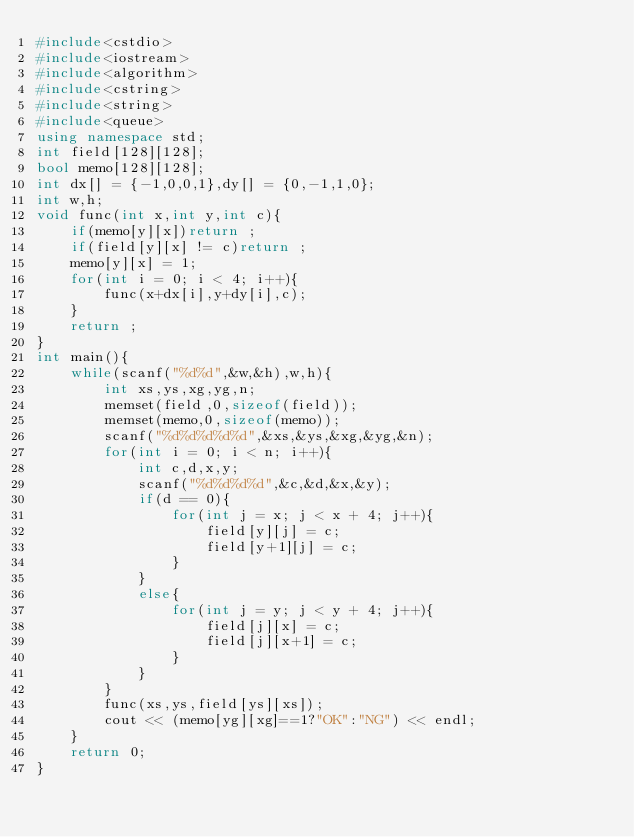<code> <loc_0><loc_0><loc_500><loc_500><_C++_>#include<cstdio>
#include<iostream>
#include<algorithm>
#include<cstring>
#include<string>
#include<queue>
using namespace std;
int field[128][128];
bool memo[128][128];
int dx[] = {-1,0,0,1},dy[] = {0,-1,1,0};
int w,h;
void func(int x,int y,int c){
	if(memo[y][x])return ;
	if(field[y][x] != c)return ;
	memo[y][x] = 1;
	for(int i = 0; i < 4; i++){
		func(x+dx[i],y+dy[i],c);
	}
	return ;
}
int main(){
	while(scanf("%d%d",&w,&h),w,h){
		int xs,ys,xg,yg,n;
		memset(field,0,sizeof(field));
		memset(memo,0,sizeof(memo));
		scanf("%d%d%d%d%d",&xs,&ys,&xg,&yg,&n);
		for(int i = 0; i < n; i++){
			int c,d,x,y;
			scanf("%d%d%d%d",&c,&d,&x,&y);
			if(d == 0){
				for(int j = x; j < x + 4; j++){
					field[y][j] = c;
					field[y+1][j] = c;
				}
			}
			else{
				for(int j = y; j < y + 4; j++){
					field[j][x] = c;
					field[j][x+1] = c;
				}
			}
		}
		func(xs,ys,field[ys][xs]);
		cout << (memo[yg][xg]==1?"OK":"NG") << endl;
	}
	return 0;
}</code> 